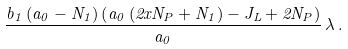Convert formula to latex. <formula><loc_0><loc_0><loc_500><loc_500>\frac { b _ { 1 } \left ( a _ { 0 } - N _ { 1 } \right ) \left ( a _ { 0 } \left ( 2 x N _ { P } + N _ { 1 } \right ) - J _ { L } + 2 N _ { P } \right ) } { a _ { 0 } } \, \lambda \, .</formula> 